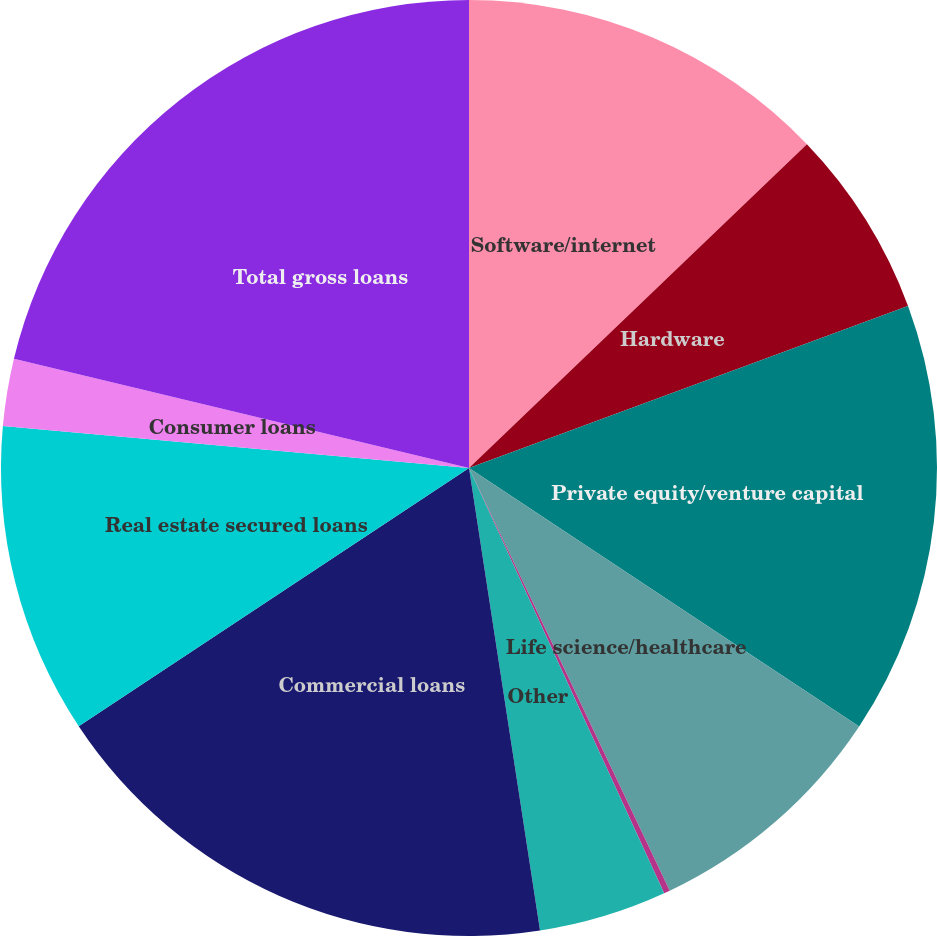Convert chart. <chart><loc_0><loc_0><loc_500><loc_500><pie_chart><fcel>Software/internet<fcel>Hardware<fcel>Private equity/venture capital<fcel>Life science/healthcare<fcel>Premium wine<fcel>Other<fcel>Commercial loans<fcel>Real estate secured loans<fcel>Consumer loans<fcel>Total gross loans<nl><fcel>12.84%<fcel>6.53%<fcel>14.94%<fcel>8.63%<fcel>0.21%<fcel>4.42%<fcel>18.12%<fcel>10.73%<fcel>2.32%<fcel>21.25%<nl></chart> 